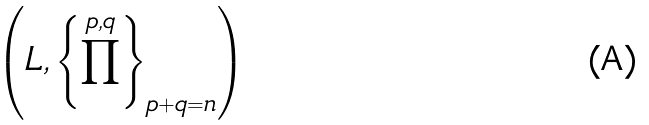Convert formula to latex. <formula><loc_0><loc_0><loc_500><loc_500>{ \left ( L , \left \{ \prod ^ { p , q } \right \} _ { p + q = n } \right ) }</formula> 